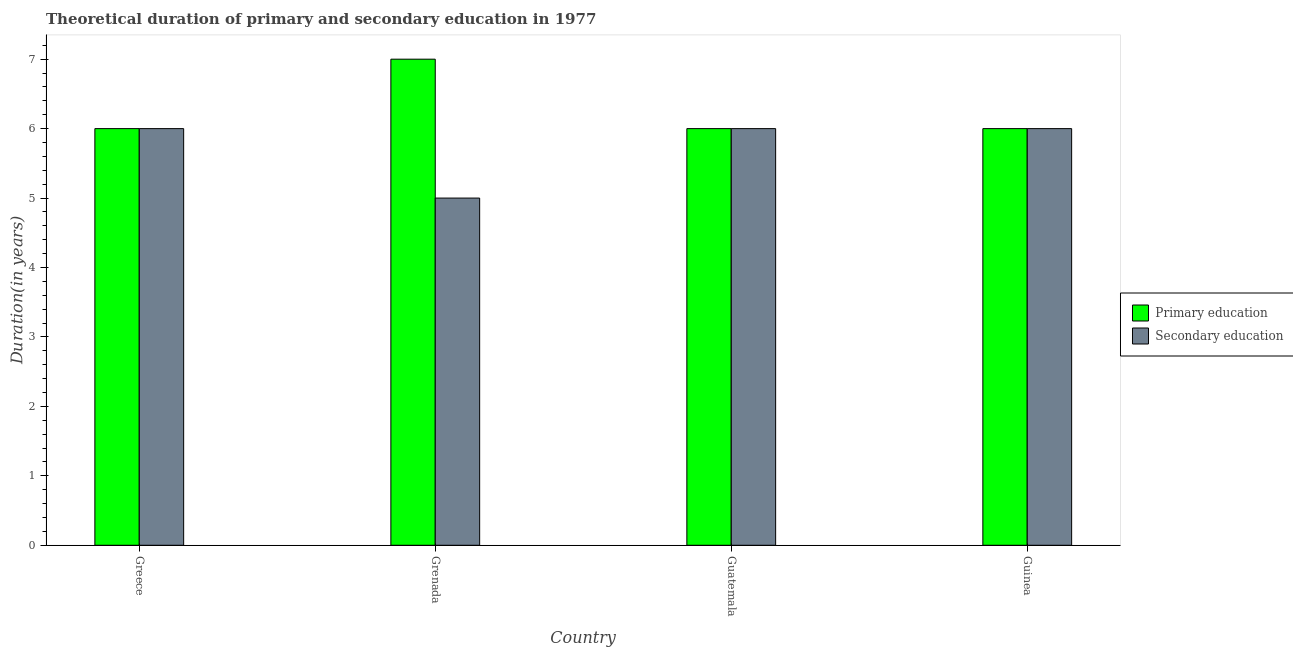How many different coloured bars are there?
Your answer should be compact. 2. Are the number of bars on each tick of the X-axis equal?
Provide a succinct answer. Yes. How many bars are there on the 4th tick from the left?
Ensure brevity in your answer.  2. How many bars are there on the 2nd tick from the right?
Make the answer very short. 2. What is the label of the 2nd group of bars from the left?
Make the answer very short. Grenada. In how many cases, is the number of bars for a given country not equal to the number of legend labels?
Provide a short and direct response. 0. What is the duration of secondary education in Greece?
Your answer should be very brief. 6. Across all countries, what is the maximum duration of primary education?
Provide a succinct answer. 7. Across all countries, what is the minimum duration of secondary education?
Give a very brief answer. 5. In which country was the duration of secondary education maximum?
Provide a short and direct response. Greece. In which country was the duration of primary education minimum?
Make the answer very short. Greece. What is the total duration of primary education in the graph?
Your answer should be very brief. 25. What is the difference between the duration of primary education in Greece and that in Grenada?
Your answer should be very brief. -1. What is the difference between the duration of secondary education in Grenada and the duration of primary education in Guatemala?
Give a very brief answer. -1. What is the average duration of primary education per country?
Offer a terse response. 6.25. In how many countries, is the duration of secondary education greater than 5.2 years?
Ensure brevity in your answer.  3. Is the duration of secondary education in Greece less than that in Guatemala?
Your answer should be compact. No. Is the difference between the duration of secondary education in Grenada and Guinea greater than the difference between the duration of primary education in Grenada and Guinea?
Keep it short and to the point. No. What is the difference between the highest and the lowest duration of primary education?
Offer a very short reply. 1. What does the 1st bar from the left in Greece represents?
Provide a short and direct response. Primary education. What does the 1st bar from the right in Guinea represents?
Offer a terse response. Secondary education. Are all the bars in the graph horizontal?
Offer a terse response. No. Are the values on the major ticks of Y-axis written in scientific E-notation?
Provide a succinct answer. No. Does the graph contain any zero values?
Your answer should be compact. No. Does the graph contain grids?
Your answer should be very brief. No. How many legend labels are there?
Your answer should be very brief. 2. How are the legend labels stacked?
Your answer should be very brief. Vertical. What is the title of the graph?
Give a very brief answer. Theoretical duration of primary and secondary education in 1977. Does "Private creditors" appear as one of the legend labels in the graph?
Provide a short and direct response. No. What is the label or title of the X-axis?
Your response must be concise. Country. What is the label or title of the Y-axis?
Your response must be concise. Duration(in years). What is the Duration(in years) of Secondary education in Greece?
Your answer should be very brief. 6. What is the Duration(in years) in Primary education in Grenada?
Make the answer very short. 7. What is the Duration(in years) of Secondary education in Guinea?
Give a very brief answer. 6. Across all countries, what is the minimum Duration(in years) of Secondary education?
Give a very brief answer. 5. What is the total Duration(in years) in Primary education in the graph?
Provide a succinct answer. 25. What is the difference between the Duration(in years) of Primary education in Greece and that in Guatemala?
Offer a terse response. 0. What is the difference between the Duration(in years) in Secondary education in Greece and that in Guatemala?
Keep it short and to the point. 0. What is the difference between the Duration(in years) in Primary education in Grenada and that in Guatemala?
Make the answer very short. 1. What is the difference between the Duration(in years) of Primary education in Grenada and that in Guinea?
Your answer should be compact. 1. What is the difference between the Duration(in years) of Primary education in Greece and the Duration(in years) of Secondary education in Guatemala?
Offer a very short reply. 0. What is the difference between the Duration(in years) in Primary education in Greece and the Duration(in years) in Secondary education in Guinea?
Offer a terse response. 0. What is the difference between the Duration(in years) of Primary education in Grenada and the Duration(in years) of Secondary education in Guatemala?
Offer a very short reply. 1. What is the average Duration(in years) of Primary education per country?
Keep it short and to the point. 6.25. What is the average Duration(in years) in Secondary education per country?
Provide a short and direct response. 5.75. What is the difference between the Duration(in years) of Primary education and Duration(in years) of Secondary education in Greece?
Provide a short and direct response. 0. What is the difference between the Duration(in years) in Primary education and Duration(in years) in Secondary education in Grenada?
Offer a terse response. 2. What is the difference between the Duration(in years) in Primary education and Duration(in years) in Secondary education in Guinea?
Give a very brief answer. 0. What is the ratio of the Duration(in years) in Primary education in Greece to that in Guatemala?
Provide a short and direct response. 1. What is the ratio of the Duration(in years) of Primary education in Greece to that in Guinea?
Your answer should be compact. 1. What is the ratio of the Duration(in years) in Secondary education in Grenada to that in Guatemala?
Make the answer very short. 0.83. What is the ratio of the Duration(in years) in Primary education in Guatemala to that in Guinea?
Offer a very short reply. 1. What is the ratio of the Duration(in years) in Secondary education in Guatemala to that in Guinea?
Make the answer very short. 1. What is the difference between the highest and the lowest Duration(in years) in Secondary education?
Your answer should be very brief. 1. 